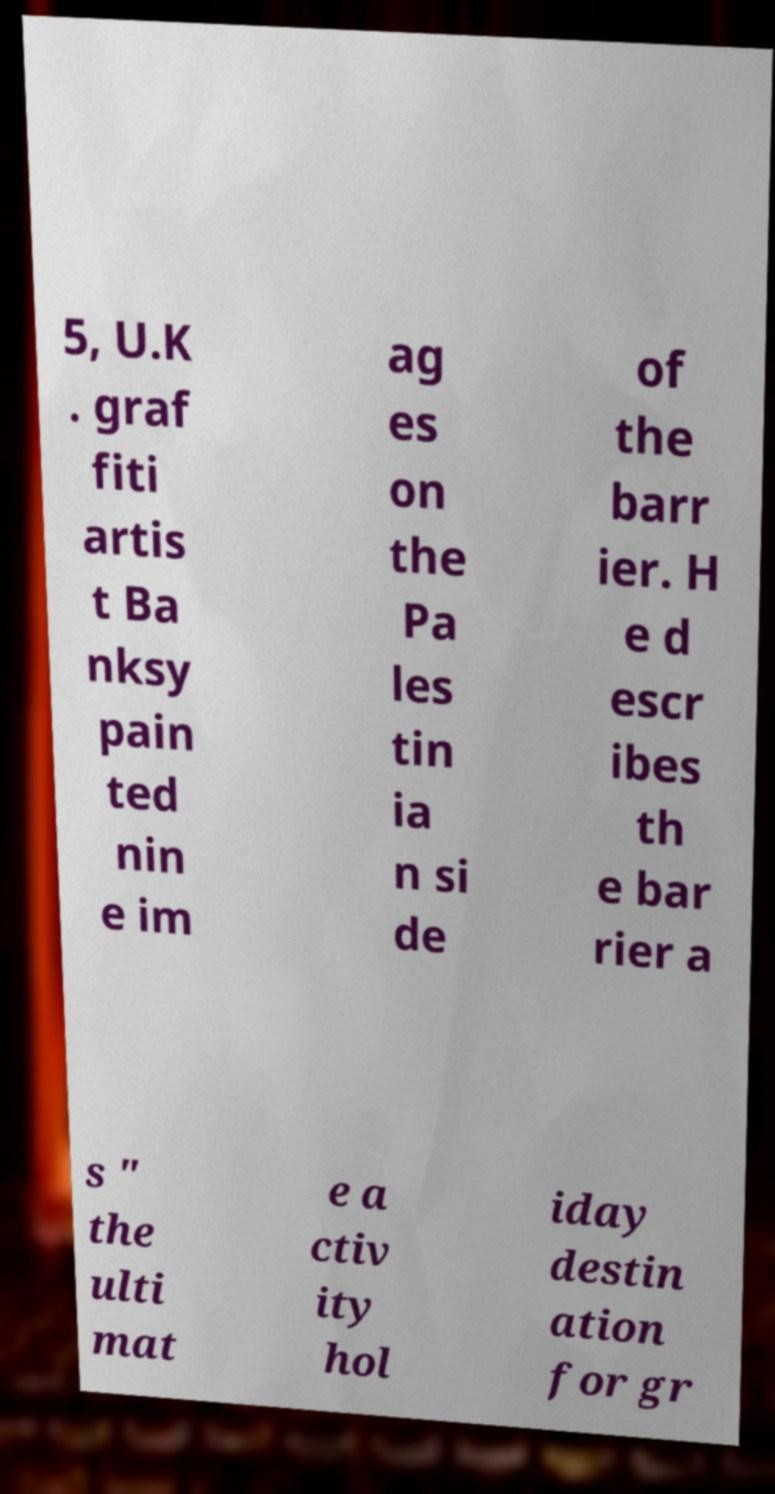What messages or text are displayed in this image? I need them in a readable, typed format. 5, U.K . graf fiti artis t Ba nksy pain ted nin e im ag es on the Pa les tin ia n si de of the barr ier. H e d escr ibes th e bar rier a s " the ulti mat e a ctiv ity hol iday destin ation for gr 